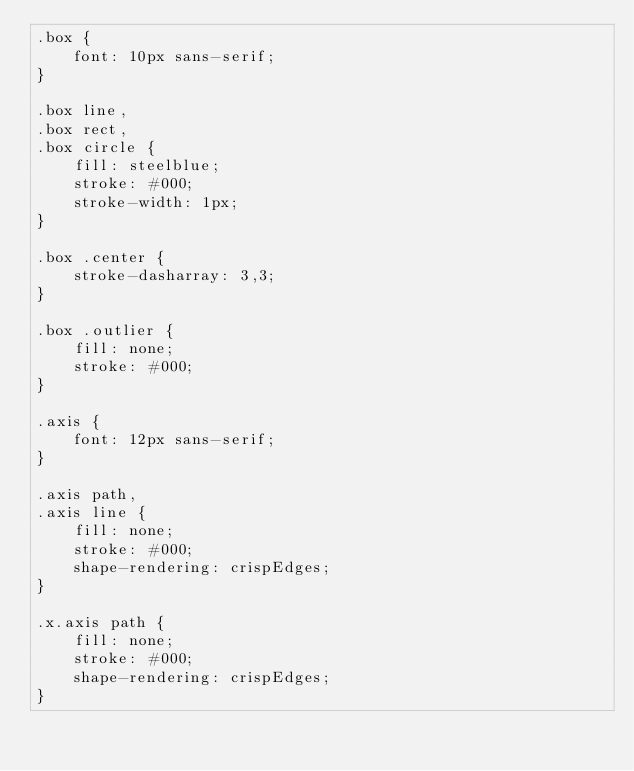Convert code to text. <code><loc_0><loc_0><loc_500><loc_500><_CSS_>.box {
    font: 10px sans-serif;
}

.box line,
.box rect,
.box circle {
    fill: steelblue;
    stroke: #000;
    stroke-width: 1px;
}

.box .center {
    stroke-dasharray: 3,3;
}

.box .outlier {
    fill: none;
    stroke: #000;
}

.axis {
    font: 12px sans-serif;
}

.axis path,
.axis line {
    fill: none;
    stroke: #000;
    shape-rendering: crispEdges;
}

.x.axis path {
    fill: none;
    stroke: #000;
    shape-rendering: crispEdges;
}</code> 